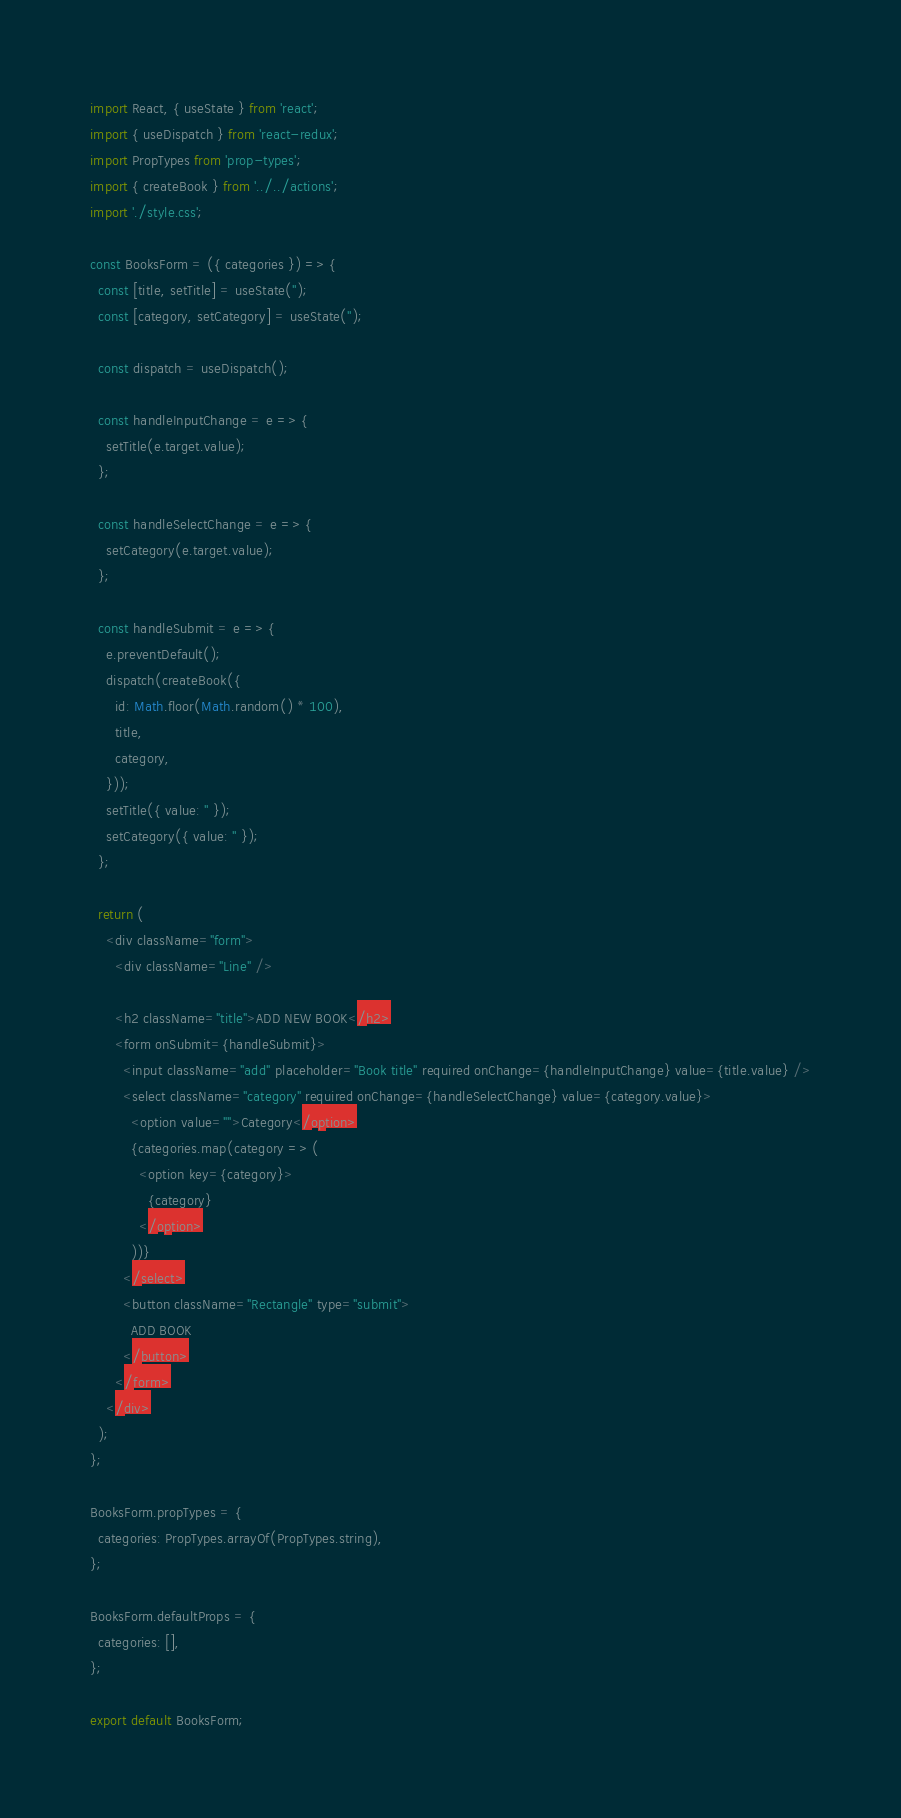Convert code to text. <code><loc_0><loc_0><loc_500><loc_500><_JavaScript_>import React, { useState } from 'react';
import { useDispatch } from 'react-redux';
import PropTypes from 'prop-types';
import { createBook } from '../../actions';
import './style.css';

const BooksForm = ({ categories }) => {
  const [title, setTitle] = useState('');
  const [category, setCategory] = useState('');

  const dispatch = useDispatch();

  const handleInputChange = e => {
    setTitle(e.target.value);
  };

  const handleSelectChange = e => {
    setCategory(e.target.value);
  };

  const handleSubmit = e => {
    e.preventDefault();
    dispatch(createBook({
      id: Math.floor(Math.random() * 100),
      title,
      category,
    }));
    setTitle({ value: '' });
    setCategory({ value: '' });
  };

  return (
    <div className="form">
      <div className="Line" />

      <h2 className="title">ADD NEW BOOK</h2>
      <form onSubmit={handleSubmit}>
        <input className="add" placeholder="Book title" required onChange={handleInputChange} value={title.value} />
        <select className="category" required onChange={handleSelectChange} value={category.value}>
          <option value="">Category</option>
          {categories.map(category => (
            <option key={category}>
              {category}
            </option>
          ))}
        </select>
        <button className="Rectangle" type="submit">
          ADD BOOK
        </button>
      </form>
    </div>
  );
};

BooksForm.propTypes = {
  categories: PropTypes.arrayOf(PropTypes.string),
};

BooksForm.defaultProps = {
  categories: [],
};

export default BooksForm;
</code> 